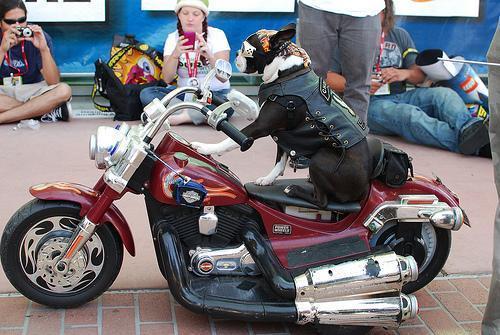How many people do you see sitting down?
Give a very brief answer. 3. How many dogs are there?
Give a very brief answer. 1. 